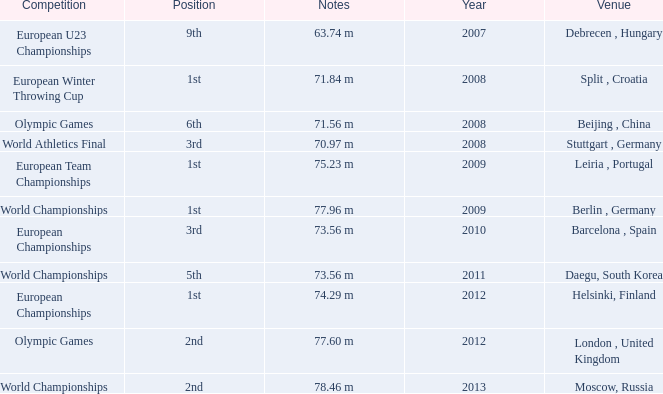Which Notes have a Competition of world championships, and a Position of 2nd? 78.46 m. 